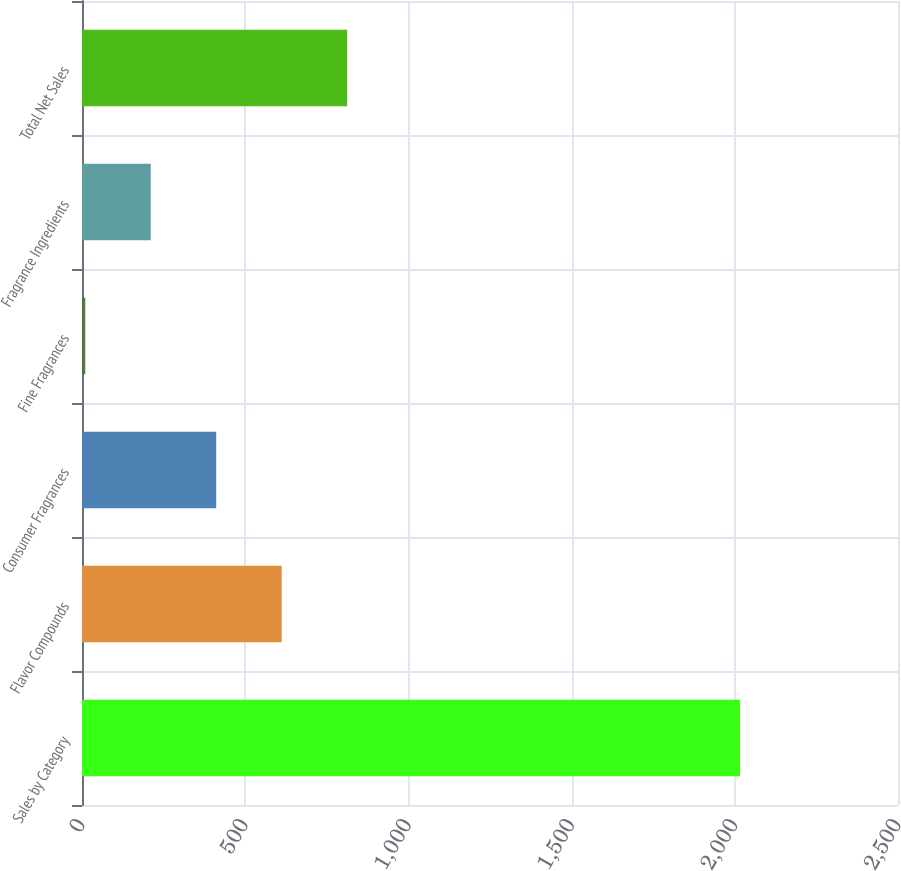Convert chart. <chart><loc_0><loc_0><loc_500><loc_500><bar_chart><fcel>Sales by Category<fcel>Flavor Compounds<fcel>Consumer Fragrances<fcel>Fine Fragrances<fcel>Fragrance Ingredients<fcel>Total Net Sales<nl><fcel>2016<fcel>611.8<fcel>411.2<fcel>10<fcel>210.6<fcel>812.4<nl></chart> 